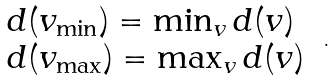<formula> <loc_0><loc_0><loc_500><loc_500>\begin{array} { l l } d ( v _ { \min } ) = \min _ { v } d ( v ) \\ d ( v _ { \max } ) = \max _ { v } d ( v ) \end{array} \ .</formula> 